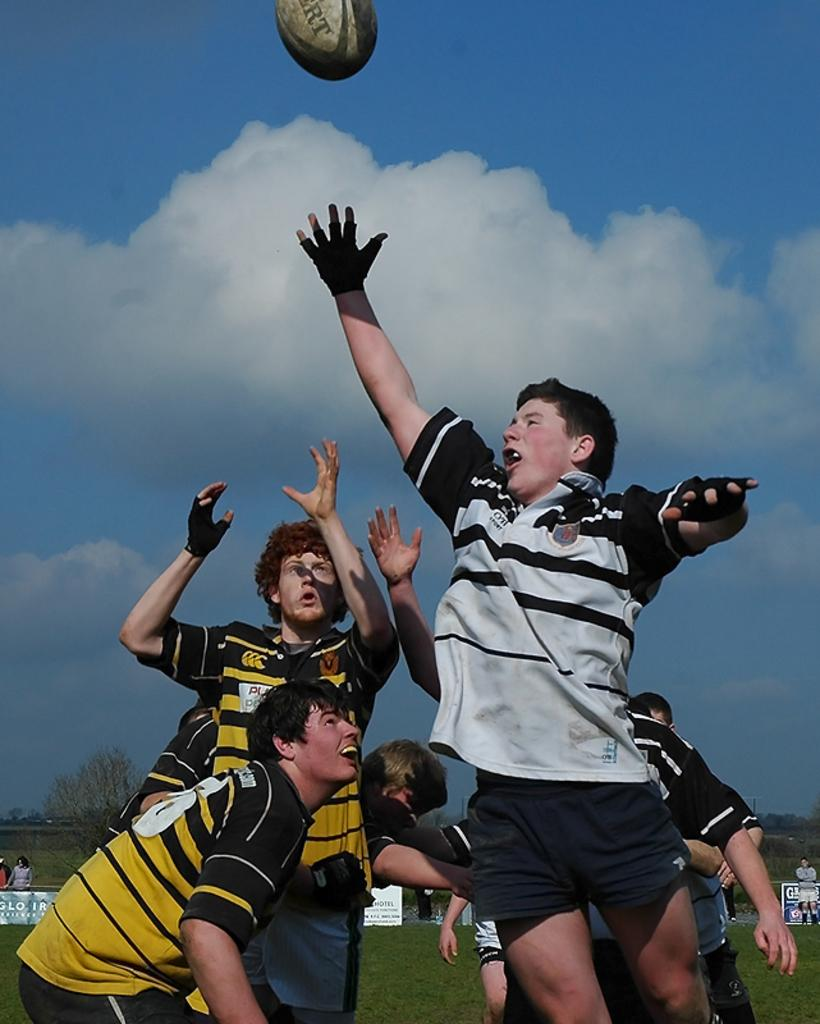What sport are the players in the image participating in? The players are playing rugby in the image. Can you describe the attire of one of the players? One of the players is wearing a black and white t-shirt. Is the player wearing the black and white t-shirt actively participating in the game? Yes, the player wearing the black and white t-shirt is playing the game. What type of vegetation can be seen in the image? There are dry trees visible in the image. What type of cheese is being used as a wrench by the player wearing the black and white t-shirt in the image? There is no cheese or wrench present in the image; the player is wearing a black and white t-shirt and participating in a rugby game. 